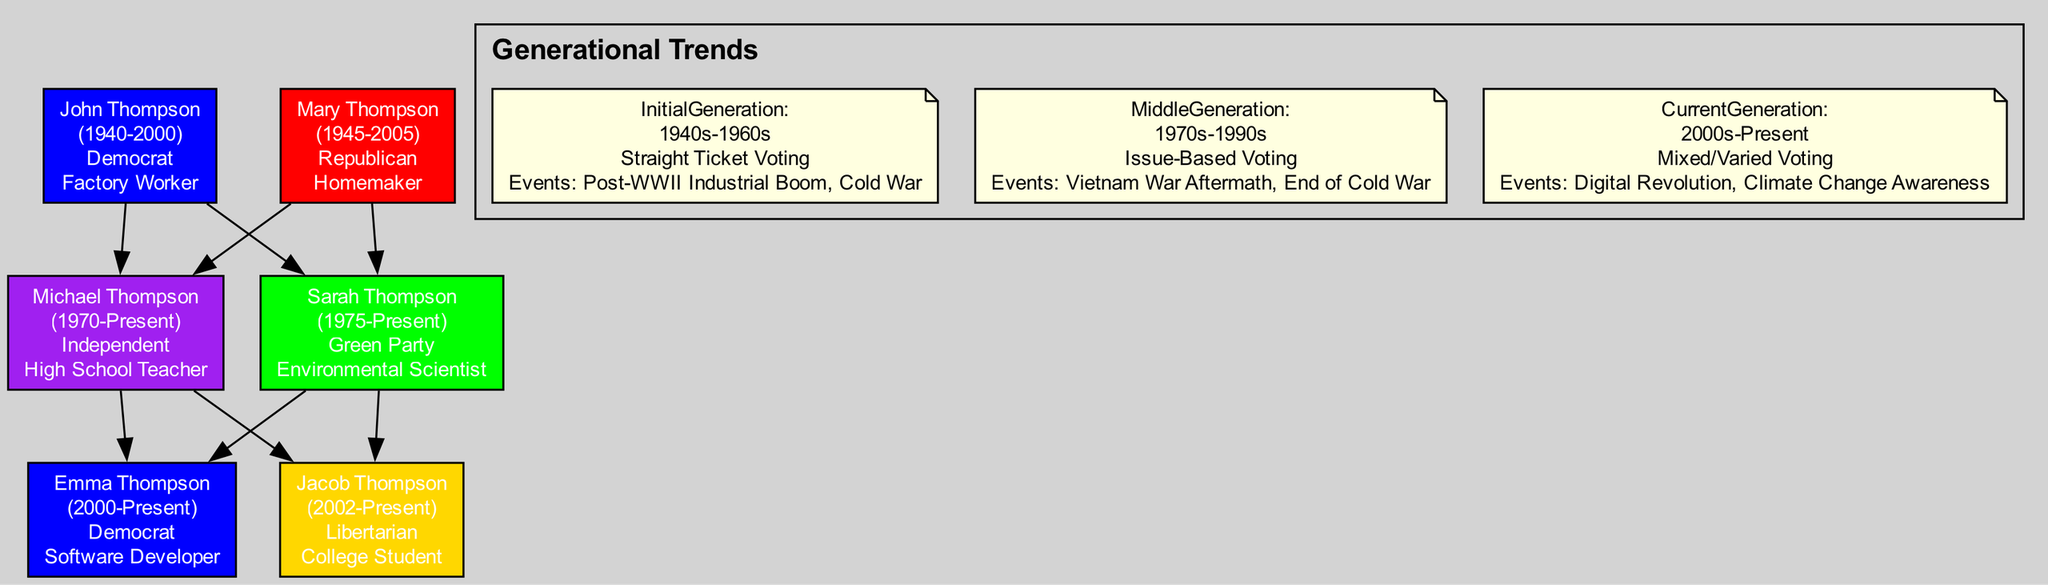What is the political affiliation of John Thompson? The diagram indicates that John Thompson's political affiliation is "Democrat," as shown in the node labeled with his name.
Answer: Democrat How many family members are there in total? By counting the nodes in the diagram, we find there are six family members listed, each represented by a node.
Answer: 6 Who is the parent of Sarah Thompson? The diagram shows that both John and Mary Thompson are parents of Sarah Thompson, as indicated by the edges leading to her node.
Answer: John and Mary Thompson What is the overall voting pattern of the current generation? The diagram states that the current generation's overall voting pattern is "Mixed/Varied Voting," as noted in the section outlining generational trends.
Answer: Mixed/Varied Voting Which sociopolitical factor influenced Michael Thompson's voting patterns? According to the diagram, the sociopolitical factors that influenced Michael Thompson include "Post-Vietnam War Era" and "Watergate Scandal." The specific factor that pertains to his voting pattern is "Post-Vietnam War Era."
Answer: Post-Vietnam War Era Who are the children of Michael Thompson? Looking at the diagram, the children of Michael Thompson are Emma Thompson and Jacob Thompson, as indicated by the edges connecting them to his node.
Answer: Emma Thompson and Jacob Thompson What political affiliation does Jacob Thompson have? The node for Jacob Thompson displays that his political affiliation is "Libertarian."
Answer: Libertarian What major sociopolitical event is associated with the initial generation? The diagram states that the major sociopolitical events associated with the initial generation include "Post-WWII Industrial Boom" and "Cold War." One of the events is "Post-WWII Industrial Boom."
Answer: Post-WWII Industrial Boom Which family member is involved in digital activism? According to the node detail for Emma Thompson, she is noted as a "Progressive Voter" with an emphasis on "Digital Activism," indicating her involvement in that area.
Answer: Emma Thompson 